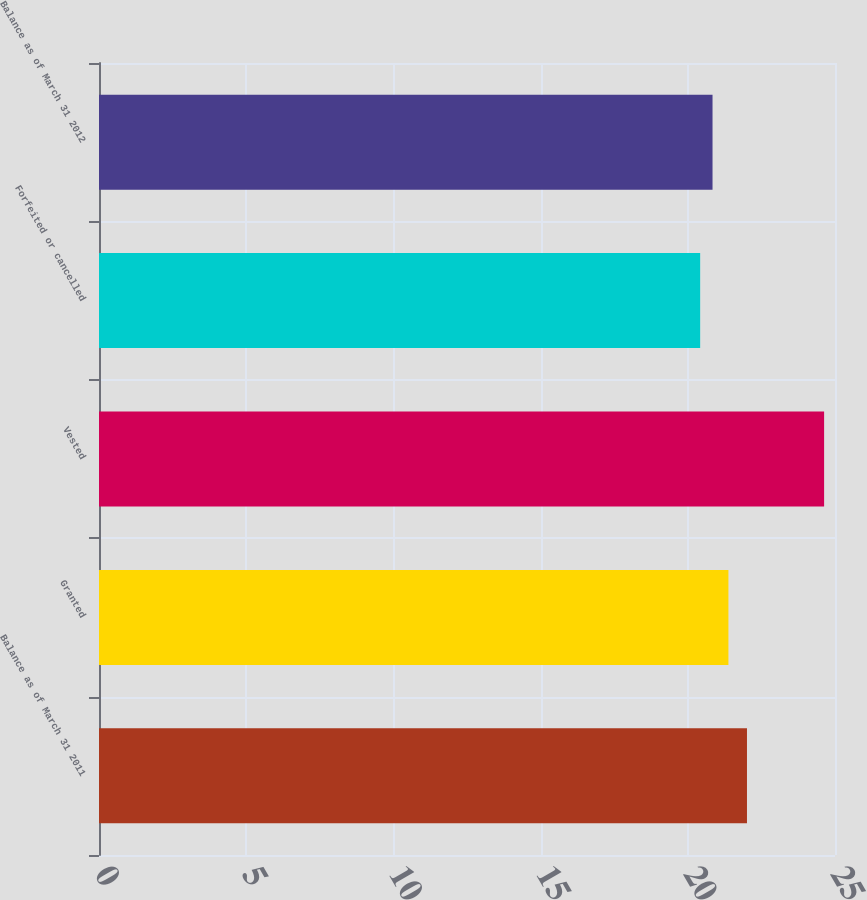Convert chart to OTSL. <chart><loc_0><loc_0><loc_500><loc_500><bar_chart><fcel>Balance as of March 31 2011<fcel>Granted<fcel>Vested<fcel>Forfeited or cancelled<fcel>Balance as of March 31 2012<nl><fcel>22.01<fcel>21.38<fcel>24.63<fcel>20.42<fcel>20.84<nl></chart> 